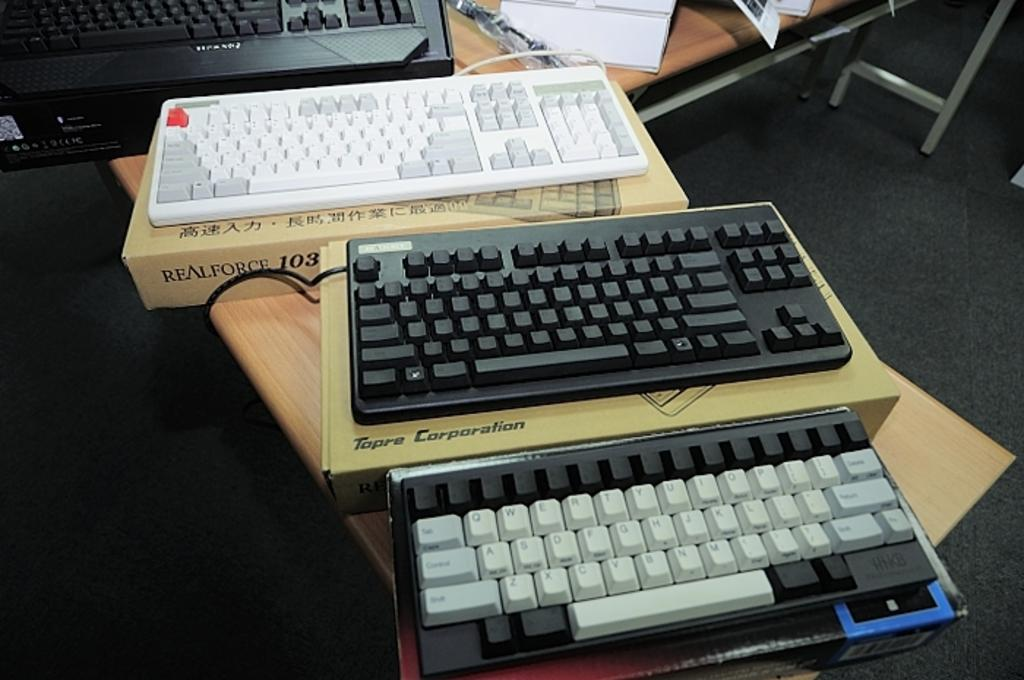<image>
Summarize the visual content of the image. A Topre Corporation keyboard in between two other keyboards. 